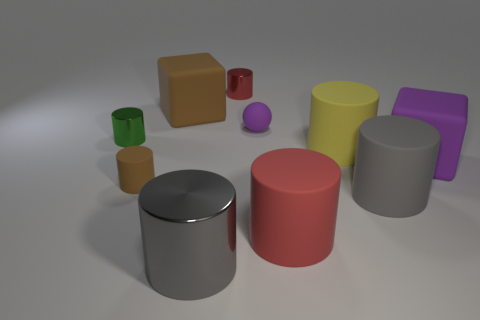How many gray cylinders must be subtracted to get 1 gray cylinders? 1 Subtract all big matte cylinders. How many cylinders are left? 4 Subtract all yellow spheres. How many red cylinders are left? 2 Subtract all red cylinders. How many cylinders are left? 5 Subtract 1 cubes. How many cubes are left? 1 Subtract all cubes. How many objects are left? 8 Add 8 yellow cylinders. How many yellow cylinders are left? 9 Add 4 large yellow things. How many large yellow things exist? 5 Subtract 1 brown blocks. How many objects are left? 9 Subtract all red spheres. Subtract all blue cubes. How many spheres are left? 1 